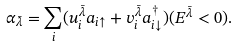<formula> <loc_0><loc_0><loc_500><loc_500>\alpha _ { \bar { \lambda } } = \sum _ { i } ( u ^ { \bar { \lambda } } _ { i } a _ { i \uparrow } + v ^ { \bar { \lambda } } _ { i } a ^ { \dag } _ { i \downarrow } ) ( E ^ { \bar { \lambda } } < 0 ) .</formula> 